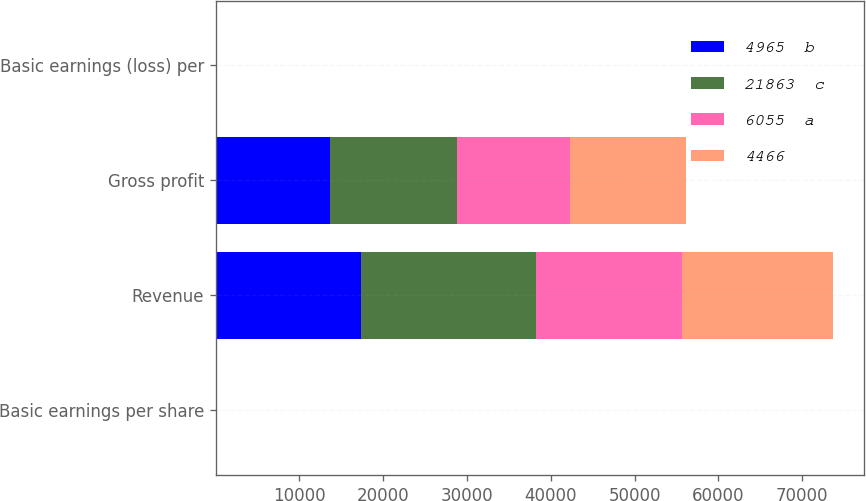Convert chart to OTSL. <chart><loc_0><loc_0><loc_500><loc_500><stacked_bar_chart><ecel><fcel>Basic earnings per share<fcel>Revenue<fcel>Gross profit<fcel>Basic earnings (loss) per<nl><fcel>4965  b<fcel>0.53<fcel>17372<fcel>13595<fcel>0.68<nl><fcel>21863  c<fcel>0.76<fcel>20885<fcel>15247<fcel>0.79<nl><fcel>6055  a<fcel>0.72<fcel>17407<fcel>13455<fcel>0.61<nl><fcel>4466<fcel>0.59<fcel>18059<fcel>13896<fcel>0.06<nl></chart> 